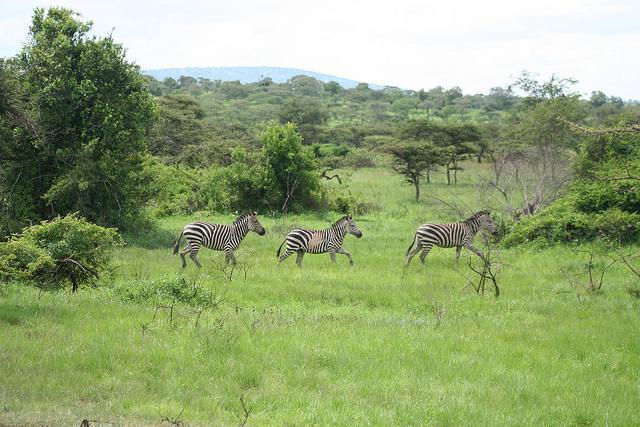What place are the zebra in?
Pick the right solution, then justify: 'Answer: answer
Rationale: rationale.'
Options: Farm, zoo, park, wilderness. Answer: wilderness.
Rationale: The zebras are outdoors in the wild and are roaming free. 